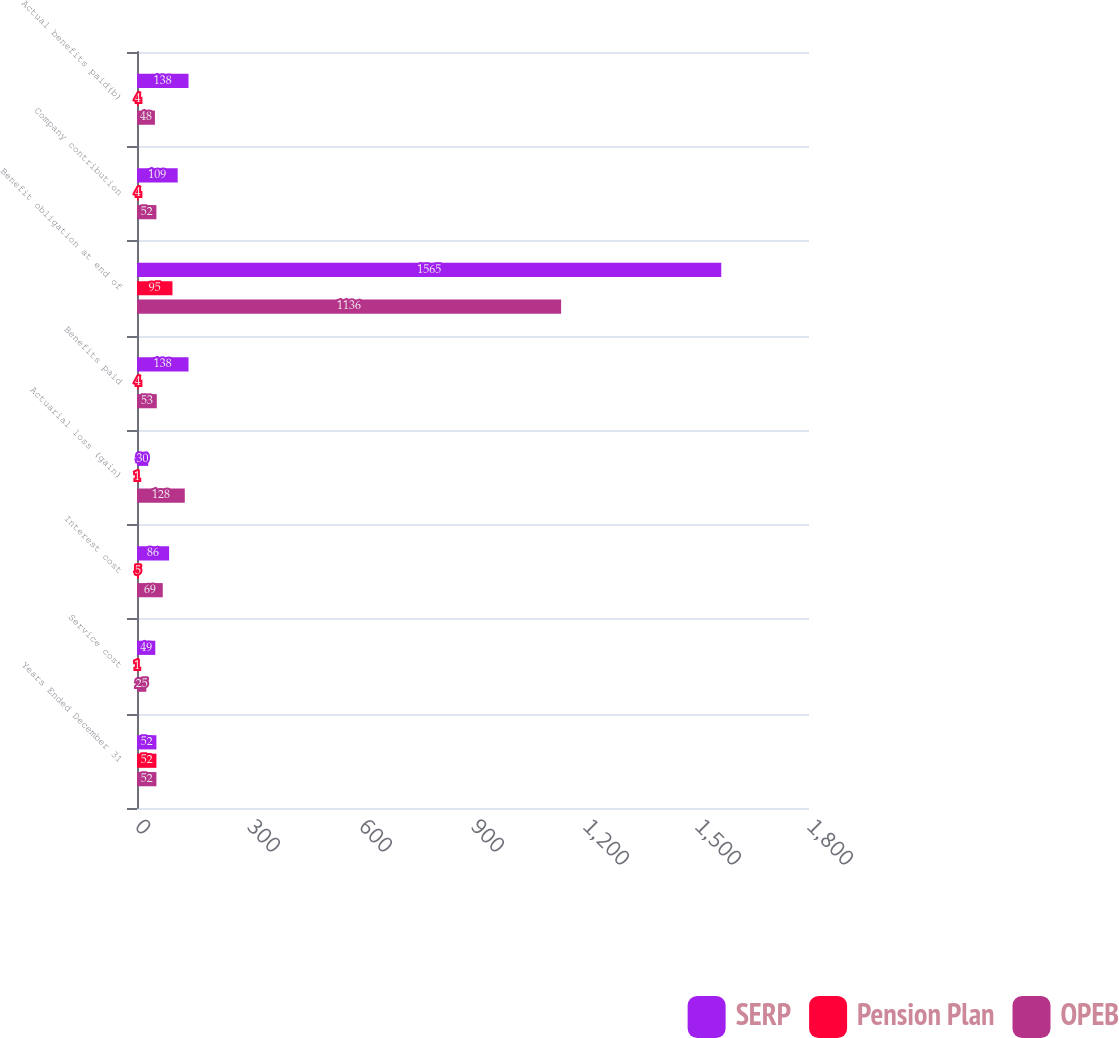Convert chart. <chart><loc_0><loc_0><loc_500><loc_500><stacked_bar_chart><ecel><fcel>Years Ended December 31<fcel>Service cost<fcel>Interest cost<fcel>Actuarial loss (gain)<fcel>Benefits paid<fcel>Benefit obligation at end of<fcel>Company contribution<fcel>Actual benefits paid(b)<nl><fcel>SERP<fcel>52<fcel>49<fcel>86<fcel>30<fcel>138<fcel>1565<fcel>109<fcel>138<nl><fcel>Pension Plan<fcel>52<fcel>1<fcel>5<fcel>1<fcel>4<fcel>95<fcel>4<fcel>4<nl><fcel>OPEB<fcel>52<fcel>25<fcel>69<fcel>128<fcel>53<fcel>1136<fcel>52<fcel>48<nl></chart> 